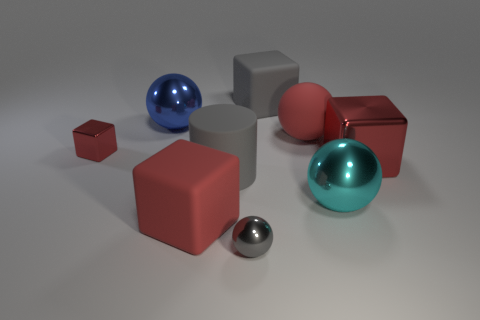What shape is the metallic object that is the same color as the small shiny block?
Provide a succinct answer. Cube. Is the size of the gray matte cylinder the same as the blue metal thing?
Your response must be concise. Yes. What is the color of the tiny shiny object that is behind the metallic cube in front of the small metal thing left of the gray shiny ball?
Provide a short and direct response. Red. What number of large cubes have the same color as the big cylinder?
Provide a short and direct response. 1. What number of large objects are either gray cylinders or cyan shiny balls?
Offer a terse response. 2. Is there a cyan object of the same shape as the large blue metallic thing?
Your answer should be very brief. Yes. Is the blue object the same shape as the tiny gray metallic object?
Ensure brevity in your answer.  Yes. There is a large ball that is on the left side of the tiny thing on the right side of the tiny red metallic cube; what is its color?
Make the answer very short. Blue. There is another metallic sphere that is the same size as the cyan shiny sphere; what color is it?
Ensure brevity in your answer.  Blue. How many matte things are either green things or large red objects?
Your answer should be compact. 2. 